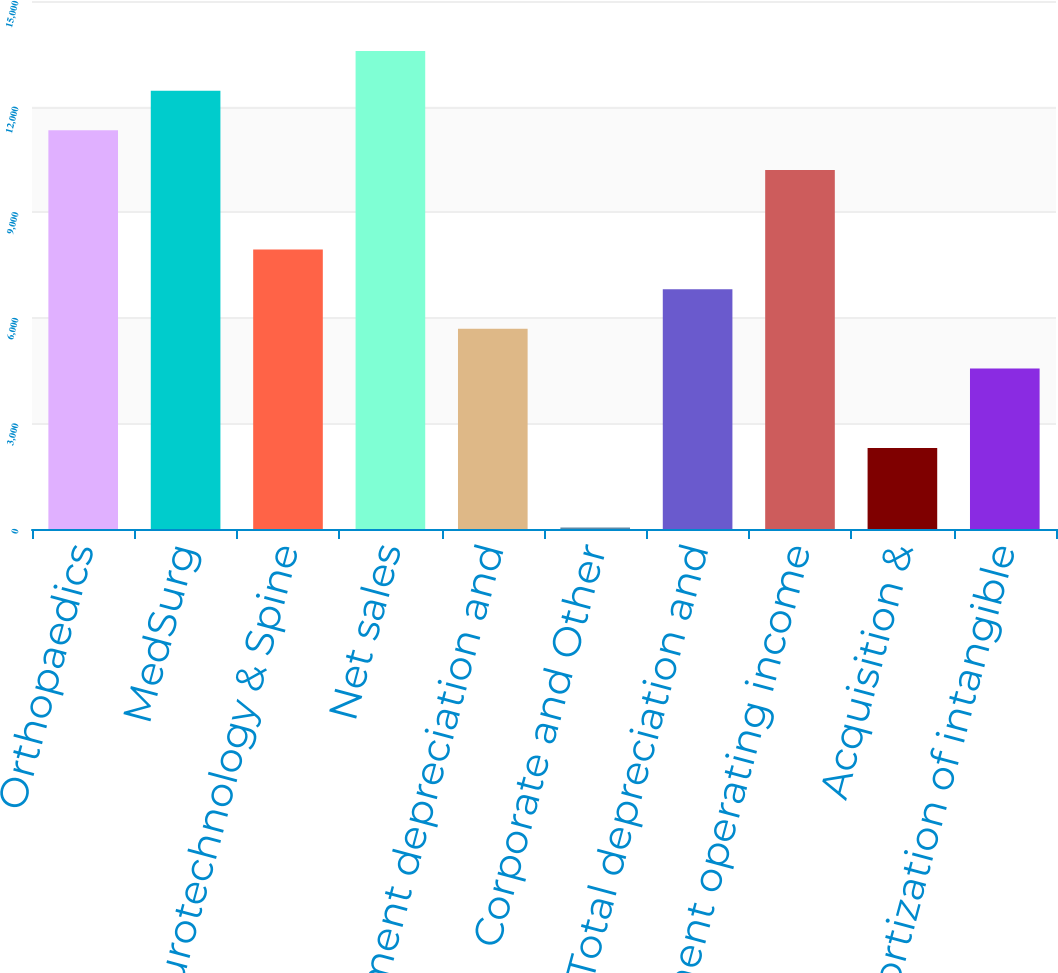Convert chart to OTSL. <chart><loc_0><loc_0><loc_500><loc_500><bar_chart><fcel>Orthopaedics<fcel>MedSurg<fcel>Neurotechnology & Spine<fcel>Net sales<fcel>Segment depreciation and<fcel>Corporate and Other<fcel>Total depreciation and<fcel>Segment operating income<fcel>Acquisition &<fcel>Amortization of intangible<nl><fcel>11325<fcel>12452.9<fcel>7941.3<fcel>13580.8<fcel>5685.5<fcel>46<fcel>6813.4<fcel>10197.1<fcel>2301.8<fcel>4557.6<nl></chart> 